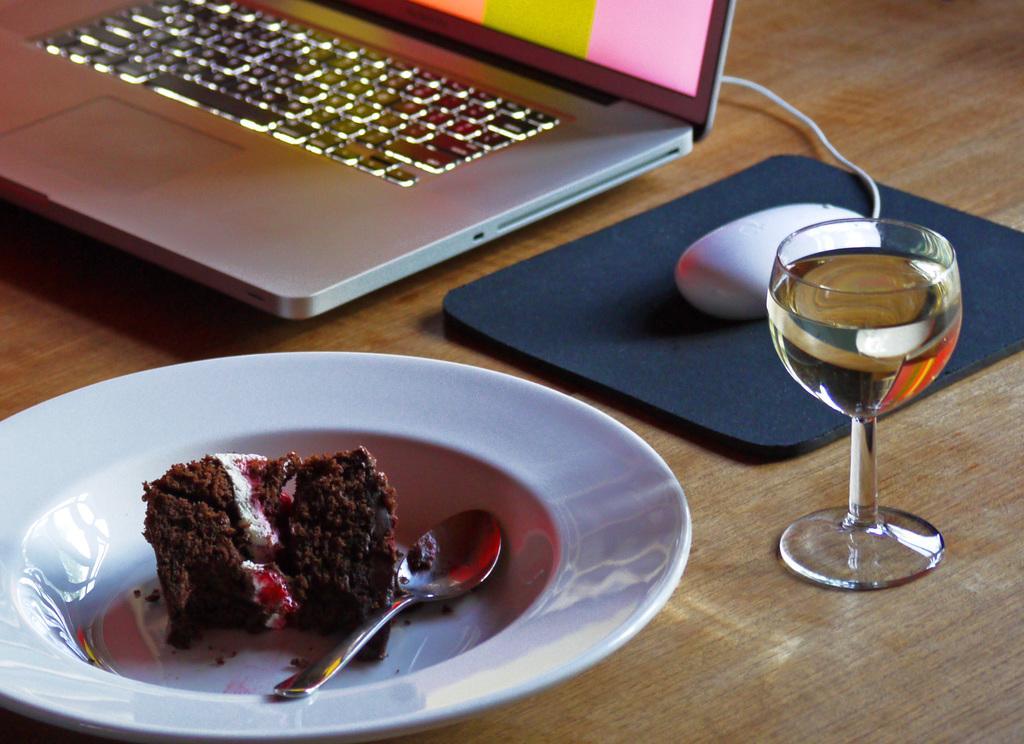In one or two sentences, can you explain what this image depicts? Here in this picture we can see a table present, on which we can see a laptop and a mouse and a glass of juice and a plate with cake and spoon on it present over there and we can also see the mouse pad present over there. 